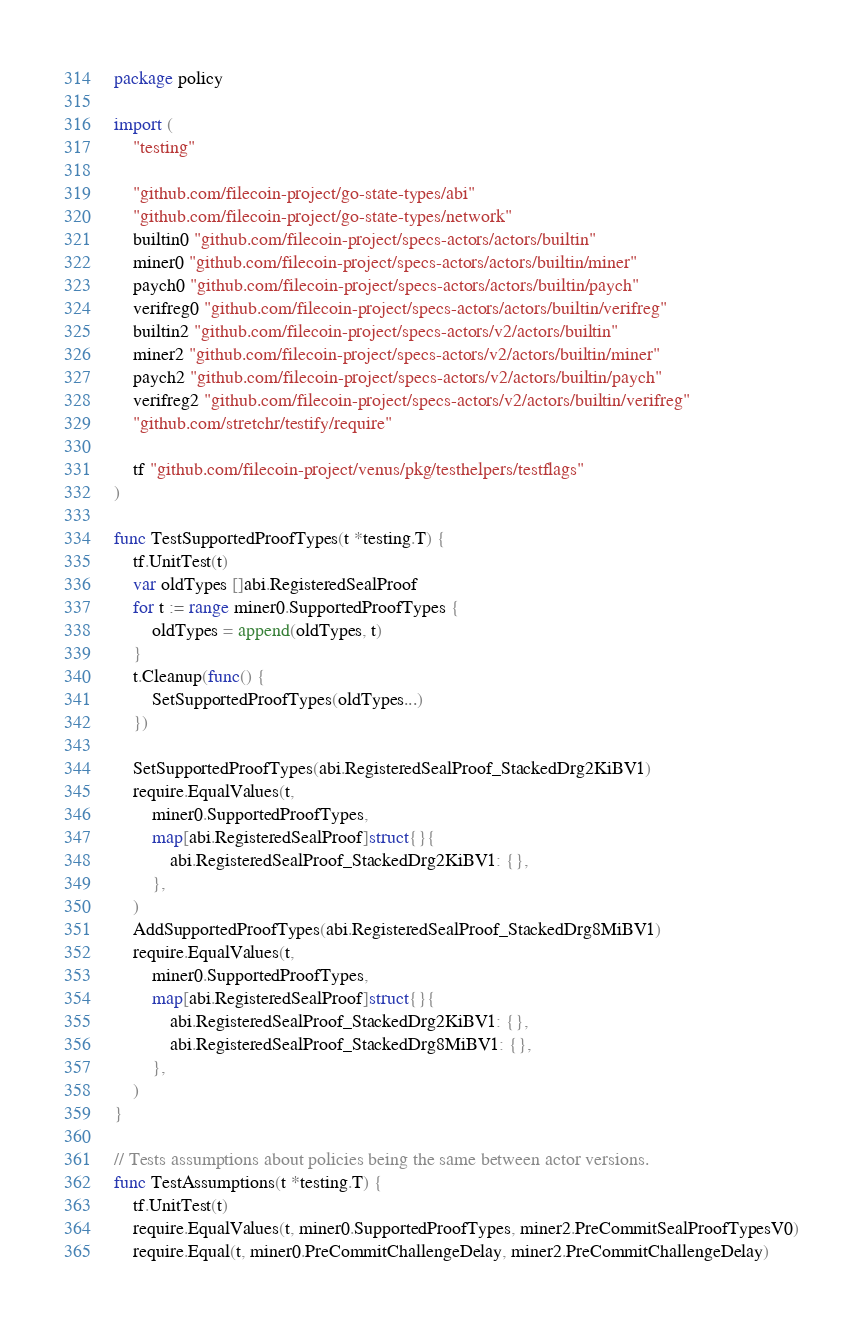Convert code to text. <code><loc_0><loc_0><loc_500><loc_500><_Go_>package policy

import (
	"testing"

	"github.com/filecoin-project/go-state-types/abi"
	"github.com/filecoin-project/go-state-types/network"
	builtin0 "github.com/filecoin-project/specs-actors/actors/builtin"
	miner0 "github.com/filecoin-project/specs-actors/actors/builtin/miner"
	paych0 "github.com/filecoin-project/specs-actors/actors/builtin/paych"
	verifreg0 "github.com/filecoin-project/specs-actors/actors/builtin/verifreg"
	builtin2 "github.com/filecoin-project/specs-actors/v2/actors/builtin"
	miner2 "github.com/filecoin-project/specs-actors/v2/actors/builtin/miner"
	paych2 "github.com/filecoin-project/specs-actors/v2/actors/builtin/paych"
	verifreg2 "github.com/filecoin-project/specs-actors/v2/actors/builtin/verifreg"
	"github.com/stretchr/testify/require"

	tf "github.com/filecoin-project/venus/pkg/testhelpers/testflags"
)

func TestSupportedProofTypes(t *testing.T) {
	tf.UnitTest(t)
	var oldTypes []abi.RegisteredSealProof
	for t := range miner0.SupportedProofTypes {
		oldTypes = append(oldTypes, t)
	}
	t.Cleanup(func() {
		SetSupportedProofTypes(oldTypes...)
	})

	SetSupportedProofTypes(abi.RegisteredSealProof_StackedDrg2KiBV1)
	require.EqualValues(t,
		miner0.SupportedProofTypes,
		map[abi.RegisteredSealProof]struct{}{
			abi.RegisteredSealProof_StackedDrg2KiBV1: {},
		},
	)
	AddSupportedProofTypes(abi.RegisteredSealProof_StackedDrg8MiBV1)
	require.EqualValues(t,
		miner0.SupportedProofTypes,
		map[abi.RegisteredSealProof]struct{}{
			abi.RegisteredSealProof_StackedDrg2KiBV1: {},
			abi.RegisteredSealProof_StackedDrg8MiBV1: {},
		},
	)
}

// Tests assumptions about policies being the same between actor versions.
func TestAssumptions(t *testing.T) {
	tf.UnitTest(t)
	require.EqualValues(t, miner0.SupportedProofTypes, miner2.PreCommitSealProofTypesV0)
	require.Equal(t, miner0.PreCommitChallengeDelay, miner2.PreCommitChallengeDelay)</code> 